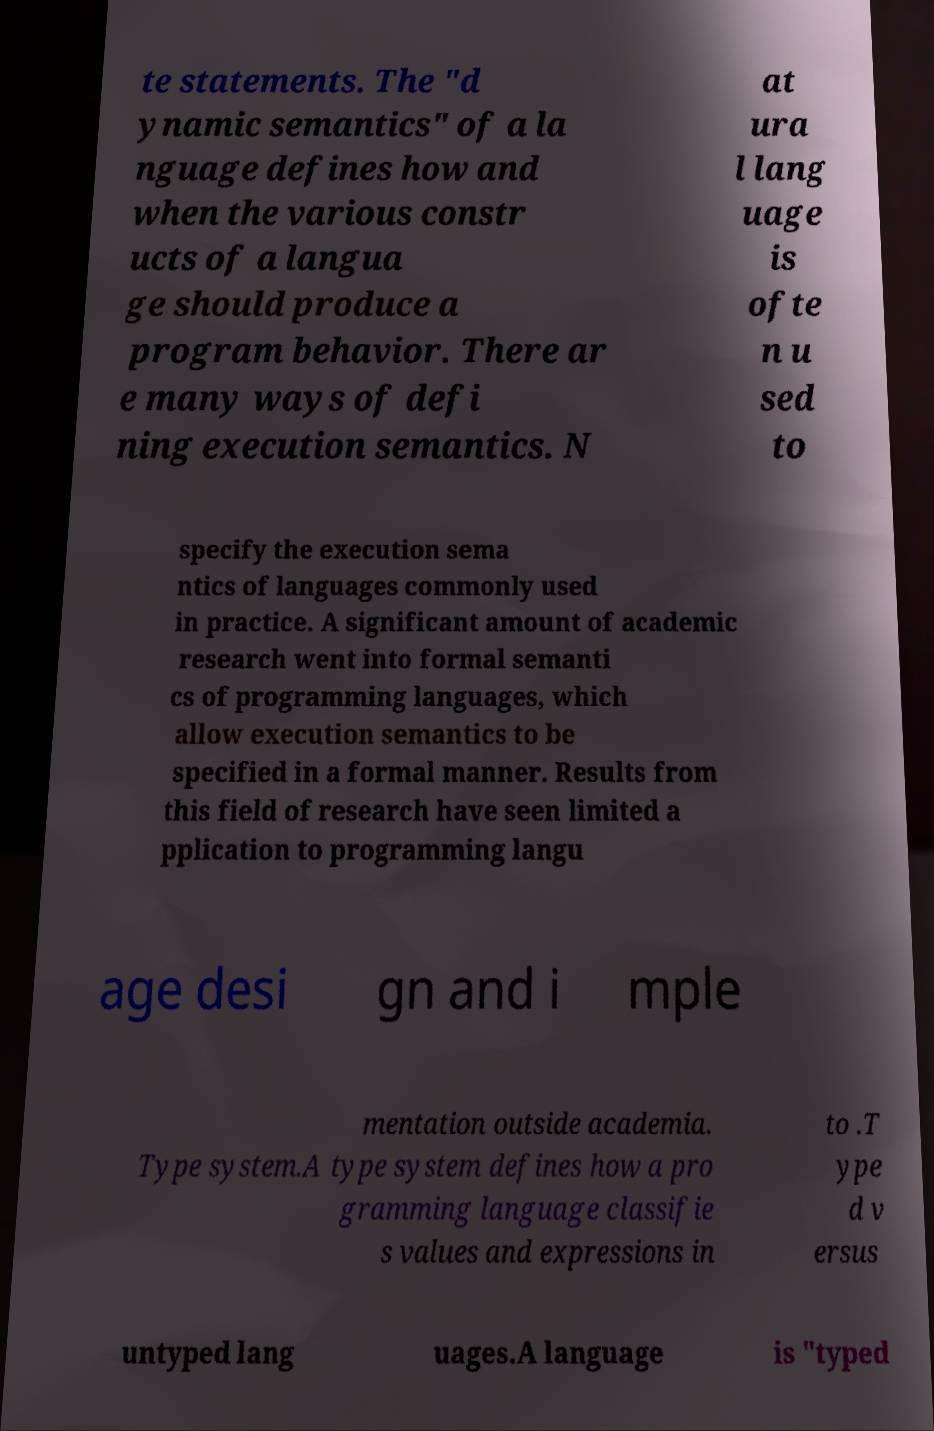For documentation purposes, I need the text within this image transcribed. Could you provide that? te statements. The "d ynamic semantics" of a la nguage defines how and when the various constr ucts of a langua ge should produce a program behavior. There ar e many ways of defi ning execution semantics. N at ura l lang uage is ofte n u sed to specify the execution sema ntics of languages commonly used in practice. A significant amount of academic research went into formal semanti cs of programming languages, which allow execution semantics to be specified in a formal manner. Results from this field of research have seen limited a pplication to programming langu age desi gn and i mple mentation outside academia. Type system.A type system defines how a pro gramming language classifie s values and expressions in to .T ype d v ersus untyped lang uages.A language is "typed 